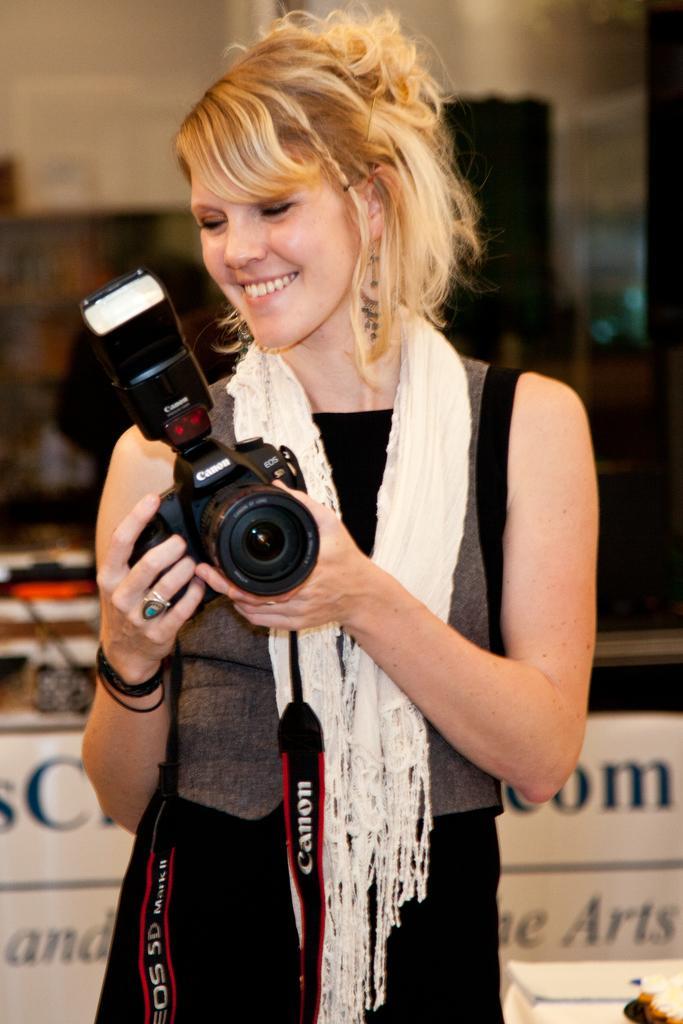Could you give a brief overview of what you see in this image? In this image i can see a woman standing and smiling holding a camera,at the back ground i can see a wooden cupboard, and a wall. 